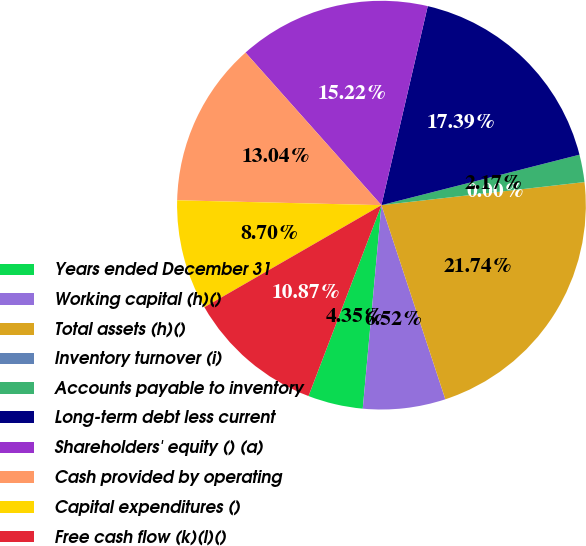Convert chart. <chart><loc_0><loc_0><loc_500><loc_500><pie_chart><fcel>Years ended December 31<fcel>Working capital (h)()<fcel>Total assets (h)()<fcel>Inventory turnover (i)<fcel>Accounts payable to inventory<fcel>Long-term debt less current<fcel>Shareholders' equity () (a)<fcel>Cash provided by operating<fcel>Capital expenditures ()<fcel>Free cash flow (k)(l)()<nl><fcel>4.35%<fcel>6.52%<fcel>21.74%<fcel>0.0%<fcel>2.17%<fcel>17.39%<fcel>15.22%<fcel>13.04%<fcel>8.7%<fcel>10.87%<nl></chart> 